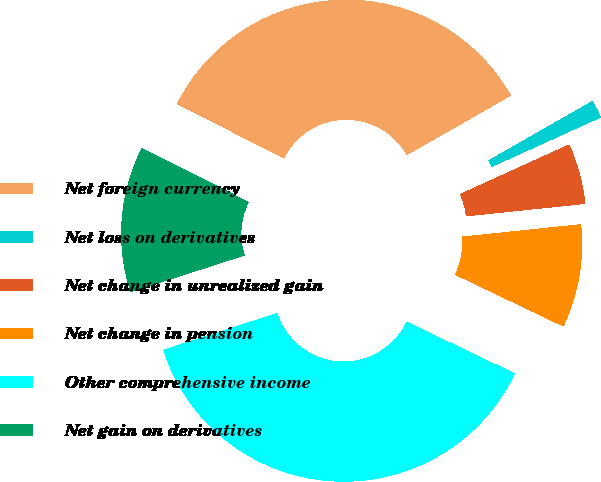Convert chart to OTSL. <chart><loc_0><loc_0><loc_500><loc_500><pie_chart><fcel>Net foreign currency<fcel>Net loss on derivatives<fcel>Net change in unrealized gain<fcel>Net change in pension<fcel>Other comprehensive income<fcel>Net gain on derivatives<nl><fcel>34.3%<fcel>1.48%<fcel>5.12%<fcel>8.76%<fcel>37.94%<fcel>12.4%<nl></chart> 